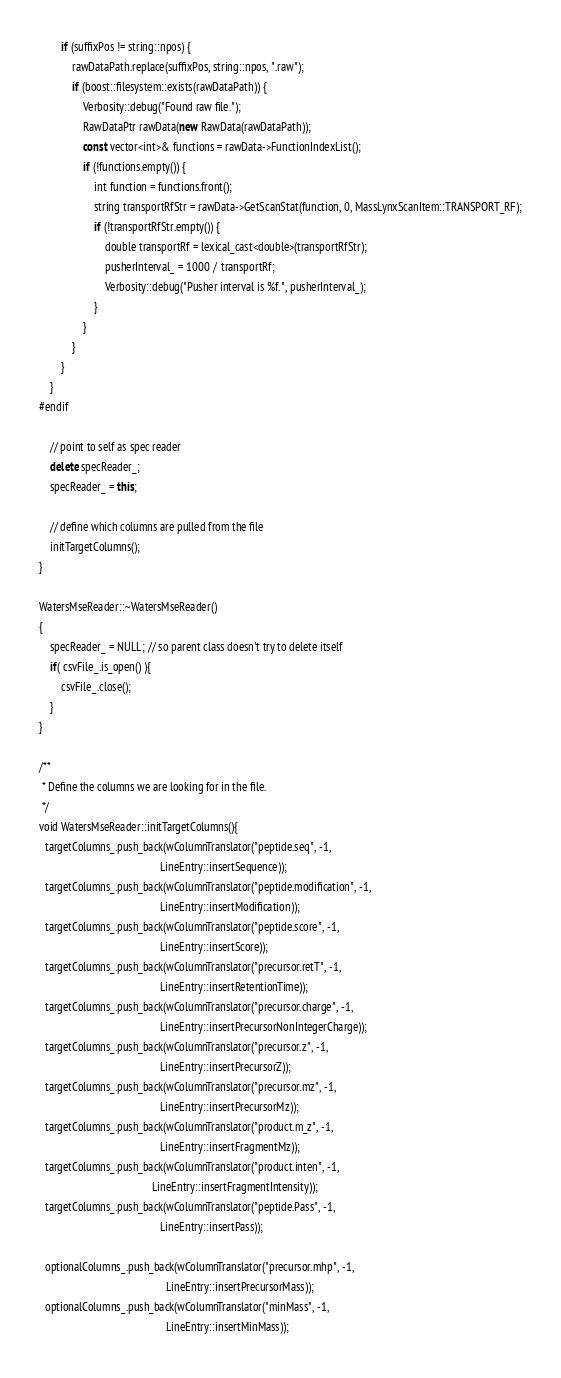<code> <loc_0><loc_0><loc_500><loc_500><_C++_>        if (suffixPos != string::npos) {
            rawDataPath.replace(suffixPos, string::npos, ".raw");
            if (boost::filesystem::exists(rawDataPath)) {
                Verbosity::debug("Found raw file.");
                RawDataPtr rawData(new RawData(rawDataPath));
                const vector<int>& functions = rawData->FunctionIndexList();
                if (!functions.empty()) {
                    int function = functions.front();
                    string transportRfStr = rawData->GetScanStat(function, 0, MassLynxScanItem::TRANSPORT_RF);
                    if (!transportRfStr.empty()) {
                        double transportRf = lexical_cast<double>(transportRfStr);
                        pusherInterval_ = 1000 / transportRf;
                        Verbosity::debug("Pusher interval is %f.", pusherInterval_);
                    }
                }
            }
        }
    }
#endif
    
    // point to self as spec reader
    delete specReader_;
    specReader_ = this;

    // define which columns are pulled from the file
    initTargetColumns();
}
    
WatersMseReader::~WatersMseReader()
{
    specReader_ = NULL; // so parent class doesn't try to delete itself
    if( csvFile_.is_open() ){
        csvFile_.close();
    }
}

/**
 * Define the columns we are looking for in the file.
 */
void WatersMseReader::initTargetColumns(){
  targetColumns_.push_back(wColumnTranslator("peptide.seq", -1, 
                                            LineEntry::insertSequence));
  targetColumns_.push_back(wColumnTranslator("peptide.modification", -1,
                                            LineEntry::insertModification));
  targetColumns_.push_back(wColumnTranslator("peptide.score", -1,
                                            LineEntry::insertScore));
  targetColumns_.push_back(wColumnTranslator("precursor.retT", -1,
                                            LineEntry::insertRetentionTime));
  targetColumns_.push_back(wColumnTranslator("precursor.charge", -1,
                                            LineEntry::insertPrecursorNonIntegerCharge));
  targetColumns_.push_back(wColumnTranslator("precursor.z", -1,
                                            LineEntry::insertPrecursorZ));
  targetColumns_.push_back(wColumnTranslator("precursor.mz", -1,
                                            LineEntry::insertPrecursorMz));
  targetColumns_.push_back(wColumnTranslator("product.m_z", -1,
                                            LineEntry::insertFragmentMz));
  targetColumns_.push_back(wColumnTranslator("product.inten", -1,
                                         LineEntry::insertFragmentIntensity));
  targetColumns_.push_back(wColumnTranslator("peptide.Pass", -1,
                                            LineEntry::insertPass));

  optionalColumns_.push_back(wColumnTranslator("precursor.mhp", -1,
                                              LineEntry::insertPrecursorMass));
  optionalColumns_.push_back(wColumnTranslator("minMass", -1,
                                              LineEntry::insertMinMass));</code> 